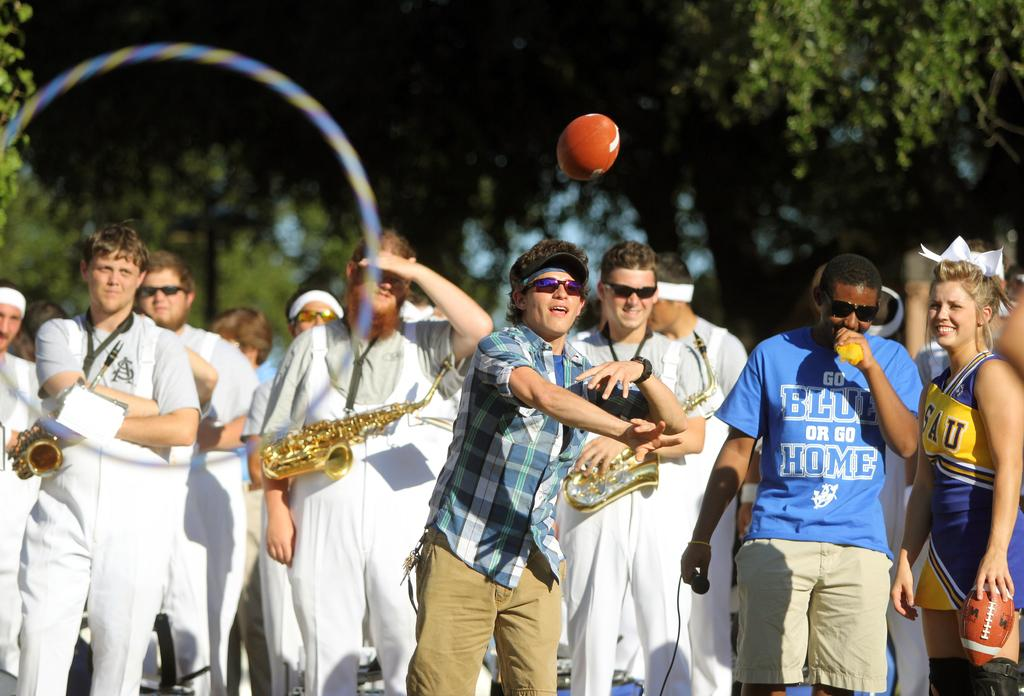<image>
Create a compact narrative representing the image presented. A man in a blue tshirt that says "Go Blue or Go Home" 